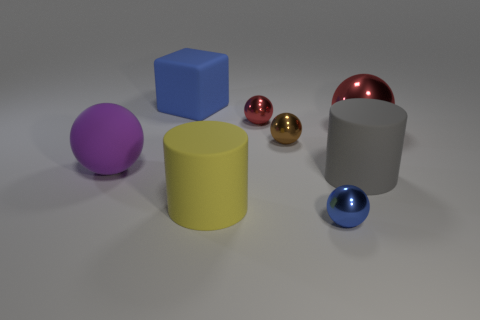Subtract 1 blocks. How many blocks are left? 0 Add 1 large purple metallic objects. How many objects exist? 9 Subtract all brown metallic spheres. How many spheres are left? 4 Subtract 0 brown cylinders. How many objects are left? 8 Subtract all blocks. How many objects are left? 7 Subtract all brown cylinders. Subtract all cyan balls. How many cylinders are left? 2 Subtract all blue cubes. How many cyan cylinders are left? 0 Subtract all small blue metallic objects. Subtract all big metallic things. How many objects are left? 6 Add 3 big blue objects. How many big blue objects are left? 4 Add 4 tiny yellow cylinders. How many tiny yellow cylinders exist? 4 